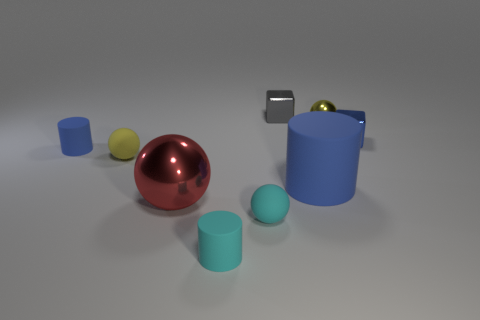Are there an equal number of yellow metal spheres left of the large blue rubber thing and small blue shiny things?
Offer a terse response. No. Is the size of the yellow matte sphere the same as the yellow metal object?
Give a very brief answer. Yes. What material is the object that is in front of the tiny yellow shiny sphere and behind the small blue matte object?
Your answer should be compact. Metal. How many tiny blue matte objects are the same shape as the big blue matte thing?
Your response must be concise. 1. There is a cube that is on the left side of the big blue rubber thing; what material is it?
Provide a short and direct response. Metal. Is the number of gray metal objects in front of the blue shiny thing less than the number of large blue matte cylinders?
Provide a short and direct response. Yes. Is the small yellow metal object the same shape as the red thing?
Ensure brevity in your answer.  Yes. Is there any other thing that has the same shape as the gray metallic thing?
Ensure brevity in your answer.  Yes. Are any small gray rubber spheres visible?
Your response must be concise. No. Is the shape of the gray thing the same as the small blue thing left of the blue block?
Your answer should be very brief. No. 